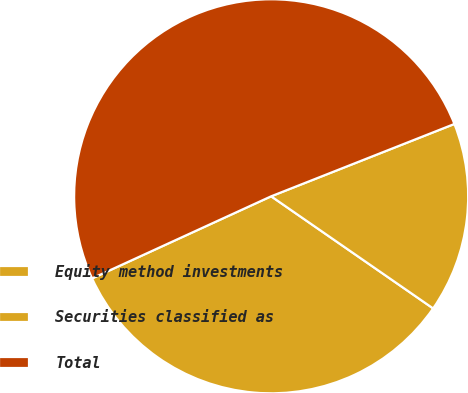Convert chart to OTSL. <chart><loc_0><loc_0><loc_500><loc_500><pie_chart><fcel>Equity method investments<fcel>Securities classified as<fcel>Total<nl><fcel>33.52%<fcel>15.62%<fcel>50.86%<nl></chart> 